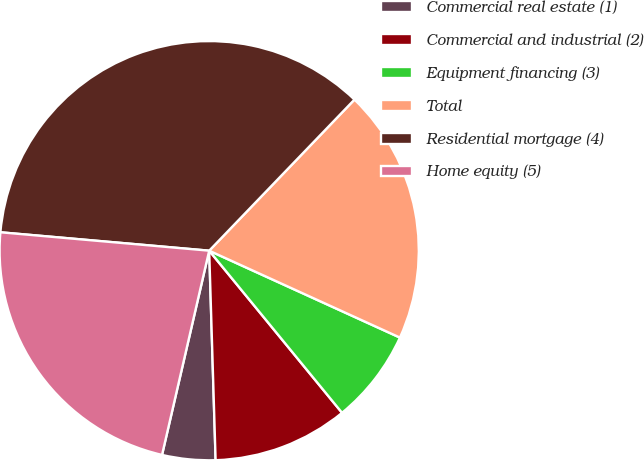Convert chart. <chart><loc_0><loc_0><loc_500><loc_500><pie_chart><fcel>Commercial real estate (1)<fcel>Commercial and industrial (2)<fcel>Equipment financing (3)<fcel>Total<fcel>Residential mortgage (4)<fcel>Home equity (5)<nl><fcel>4.1%<fcel>10.44%<fcel>7.27%<fcel>19.62%<fcel>35.79%<fcel>22.79%<nl></chart> 